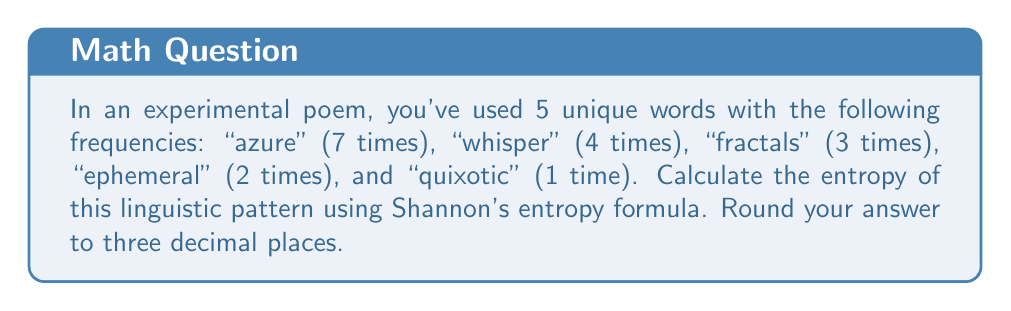Solve this math problem. To calculate the entropy of this linguistic pattern, we'll use Shannon's entropy formula:

$$ H = -\sum_{i=1}^{n} p_i \log_2(p_i) $$

Where $H$ is the entropy, $p_i$ is the probability of each word, and $n$ is the number of unique words.

Step 1: Calculate the total number of words.
Total words = 7 + 4 + 3 + 2 + 1 = 17

Step 2: Calculate the probability of each word.
$p(\text{azure}) = 7/17$
$p(\text{whisper}) = 4/17$
$p(\text{fractals}) = 3/17$
$p(\text{ephemeral}) = 2/17$
$p(\text{quixotic}) = 1/17$

Step 3: Apply Shannon's entropy formula.

$$ H = -(\frac{7}{17} \log_2(\frac{7}{17}) + \frac{4}{17} \log_2(\frac{4}{17}) + \frac{3}{17} \log_2(\frac{3}{17}) + \frac{2}{17} \log_2(\frac{2}{17}) + \frac{1}{17} \log_2(\frac{1}{17})) $$

Step 4: Calculate each term and sum them up.
$$ H = -((-0.5237) + (-0.3789) + (-0.3230) + (-0.2431) + (-0.1490)) $$
$$ H = 1.6177 $$

Step 5: Round to three decimal places.
$$ H \approx 1.618 $$
Answer: 1.618 